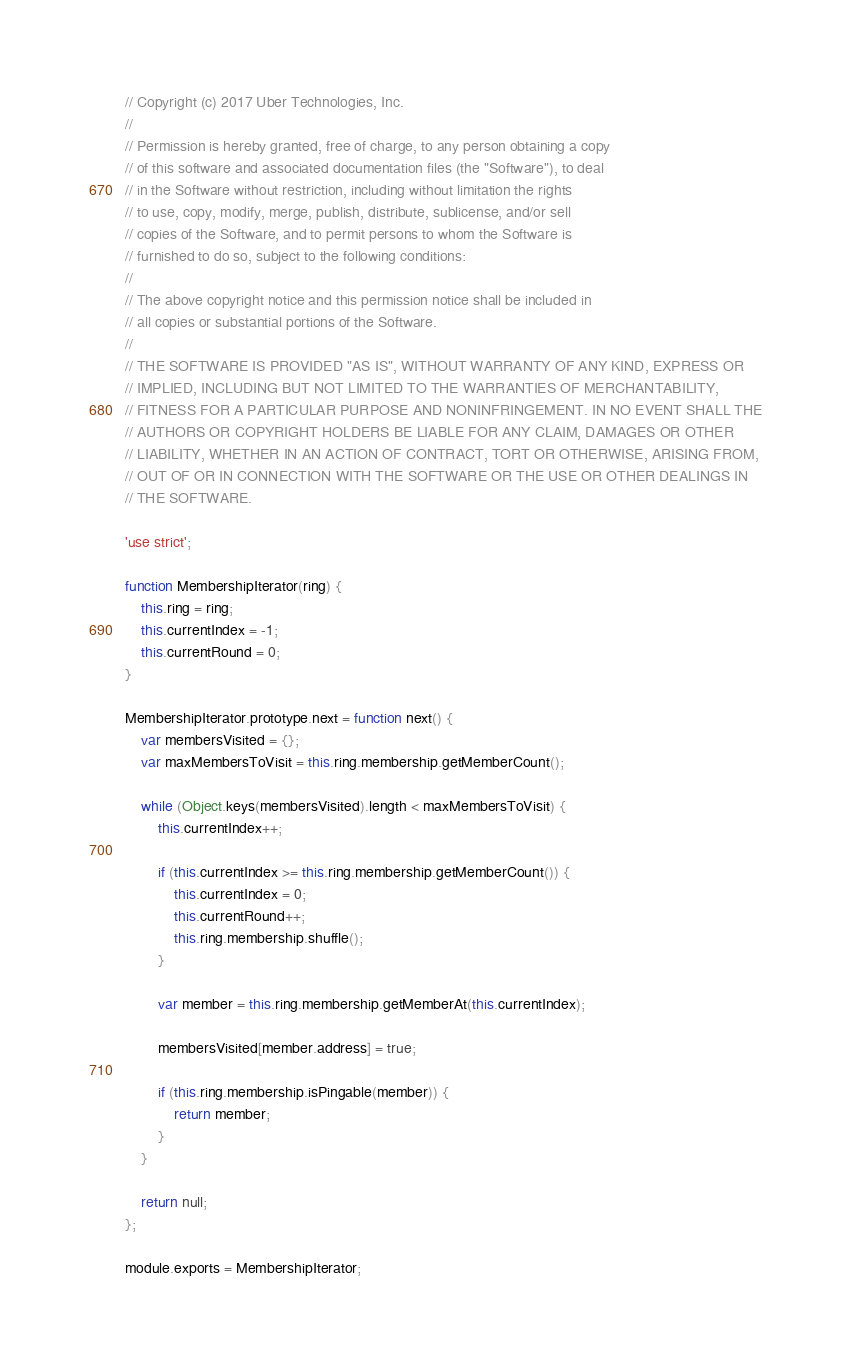<code> <loc_0><loc_0><loc_500><loc_500><_JavaScript_>// Copyright (c) 2017 Uber Technologies, Inc.
//
// Permission is hereby granted, free of charge, to any person obtaining a copy
// of this software and associated documentation files (the "Software"), to deal
// in the Software without restriction, including without limitation the rights
// to use, copy, modify, merge, publish, distribute, sublicense, and/or sell
// copies of the Software, and to permit persons to whom the Software is
// furnished to do so, subject to the following conditions:
//
// The above copyright notice and this permission notice shall be included in
// all copies or substantial portions of the Software.
//
// THE SOFTWARE IS PROVIDED "AS IS", WITHOUT WARRANTY OF ANY KIND, EXPRESS OR
// IMPLIED, INCLUDING BUT NOT LIMITED TO THE WARRANTIES OF MERCHANTABILITY,
// FITNESS FOR A PARTICULAR PURPOSE AND NONINFRINGEMENT. IN NO EVENT SHALL THE
// AUTHORS OR COPYRIGHT HOLDERS BE LIABLE FOR ANY CLAIM, DAMAGES OR OTHER
// LIABILITY, WHETHER IN AN ACTION OF CONTRACT, TORT OR OTHERWISE, ARISING FROM,
// OUT OF OR IN CONNECTION WITH THE SOFTWARE OR THE USE OR OTHER DEALINGS IN
// THE SOFTWARE.

'use strict';

function MembershipIterator(ring) {
    this.ring = ring;
    this.currentIndex = -1;
    this.currentRound = 0;
}

MembershipIterator.prototype.next = function next() {
    var membersVisited = {};
    var maxMembersToVisit = this.ring.membership.getMemberCount();

    while (Object.keys(membersVisited).length < maxMembersToVisit) {
        this.currentIndex++;

        if (this.currentIndex >= this.ring.membership.getMemberCount()) {
            this.currentIndex = 0;
            this.currentRound++;
            this.ring.membership.shuffle();
        }

        var member = this.ring.membership.getMemberAt(this.currentIndex);

        membersVisited[member.address] = true;

        if (this.ring.membership.isPingable(member)) {
            return member;
        }
    }

    return null;
};

module.exports = MembershipIterator;
</code> 